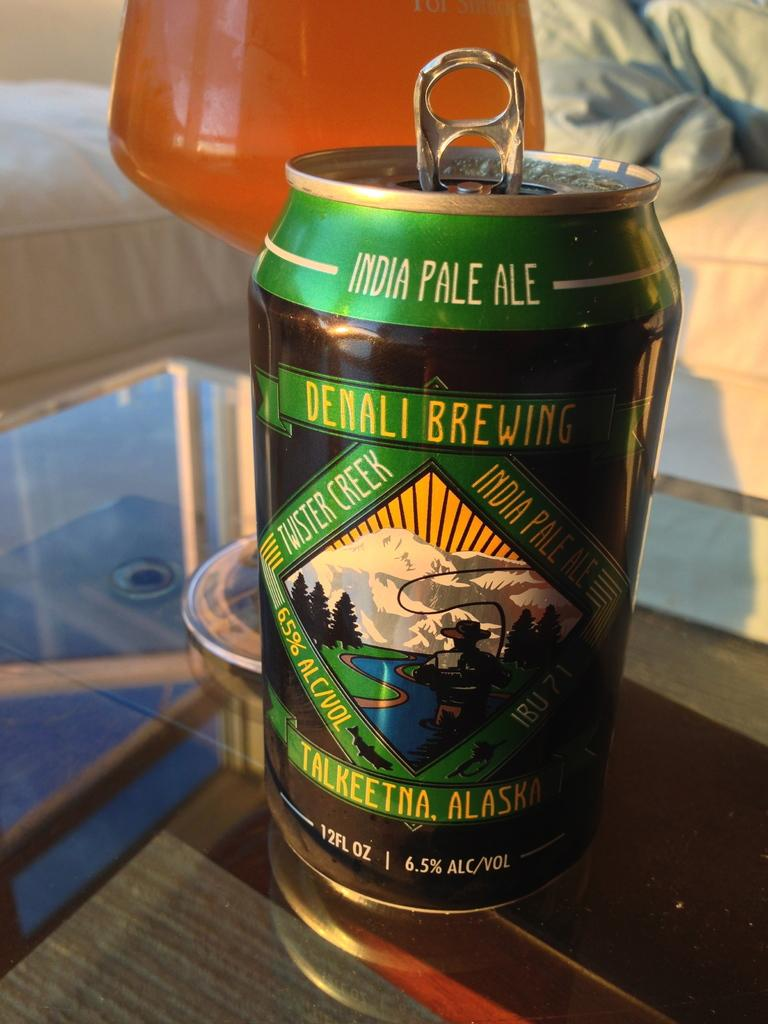<image>
Provide a brief description of the given image. A can of Denali Brewing India Pale Ale is on a glass table next to a glass. 